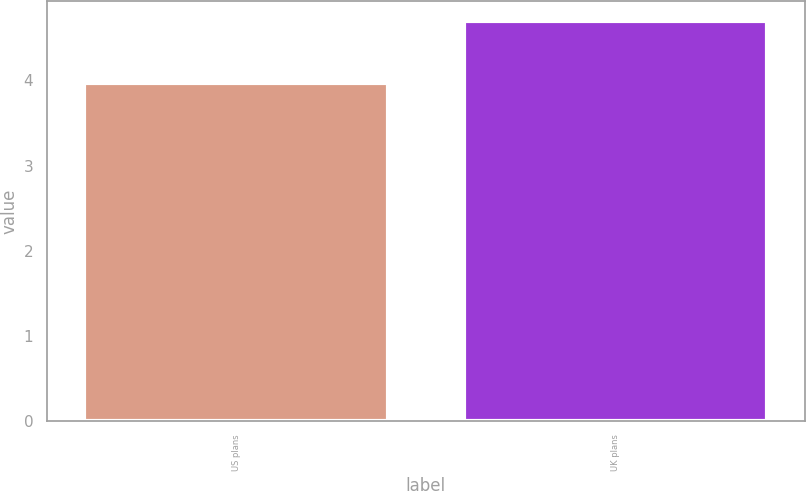<chart> <loc_0><loc_0><loc_500><loc_500><bar_chart><fcel>US plans<fcel>UK plans<nl><fcel>3.97<fcel>4.7<nl></chart> 